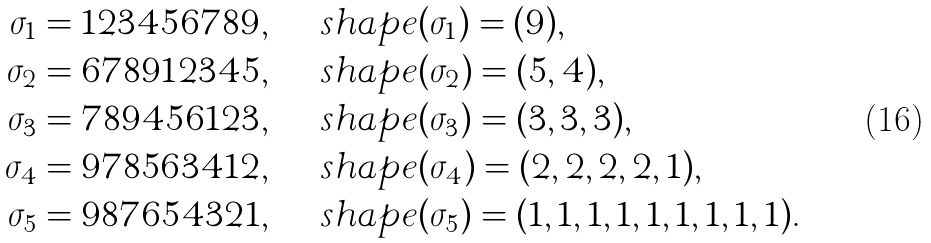<formula> <loc_0><loc_0><loc_500><loc_500>\sigma _ { 1 } & = 1 2 3 4 5 6 7 8 9 , \quad \ s h a p e ( \sigma _ { 1 } ) = ( 9 ) , \\ \sigma _ { 2 } & = 6 7 8 9 1 2 3 4 5 , \quad \ s h a p e ( \sigma _ { 2 } ) = ( 5 , 4 ) , \\ \sigma _ { 3 } & = 7 8 9 4 5 6 1 2 3 , \quad \ s h a p e ( \sigma _ { 3 } ) = ( 3 , 3 , 3 ) , \\ \sigma _ { 4 } & = 9 7 8 5 6 3 4 1 2 , \quad \ s h a p e ( \sigma _ { 4 } ) = ( 2 , 2 , 2 , 2 , 1 ) , \\ \sigma _ { 5 } & = 9 8 7 6 5 4 3 2 1 , \quad \ s h a p e ( \sigma _ { 5 } ) = ( 1 , 1 , 1 , 1 , 1 , 1 , 1 , 1 , 1 ) .</formula> 